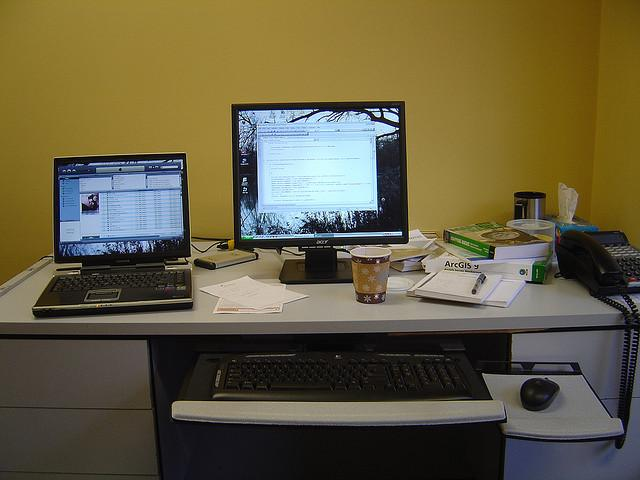Why would someone sit here? work 